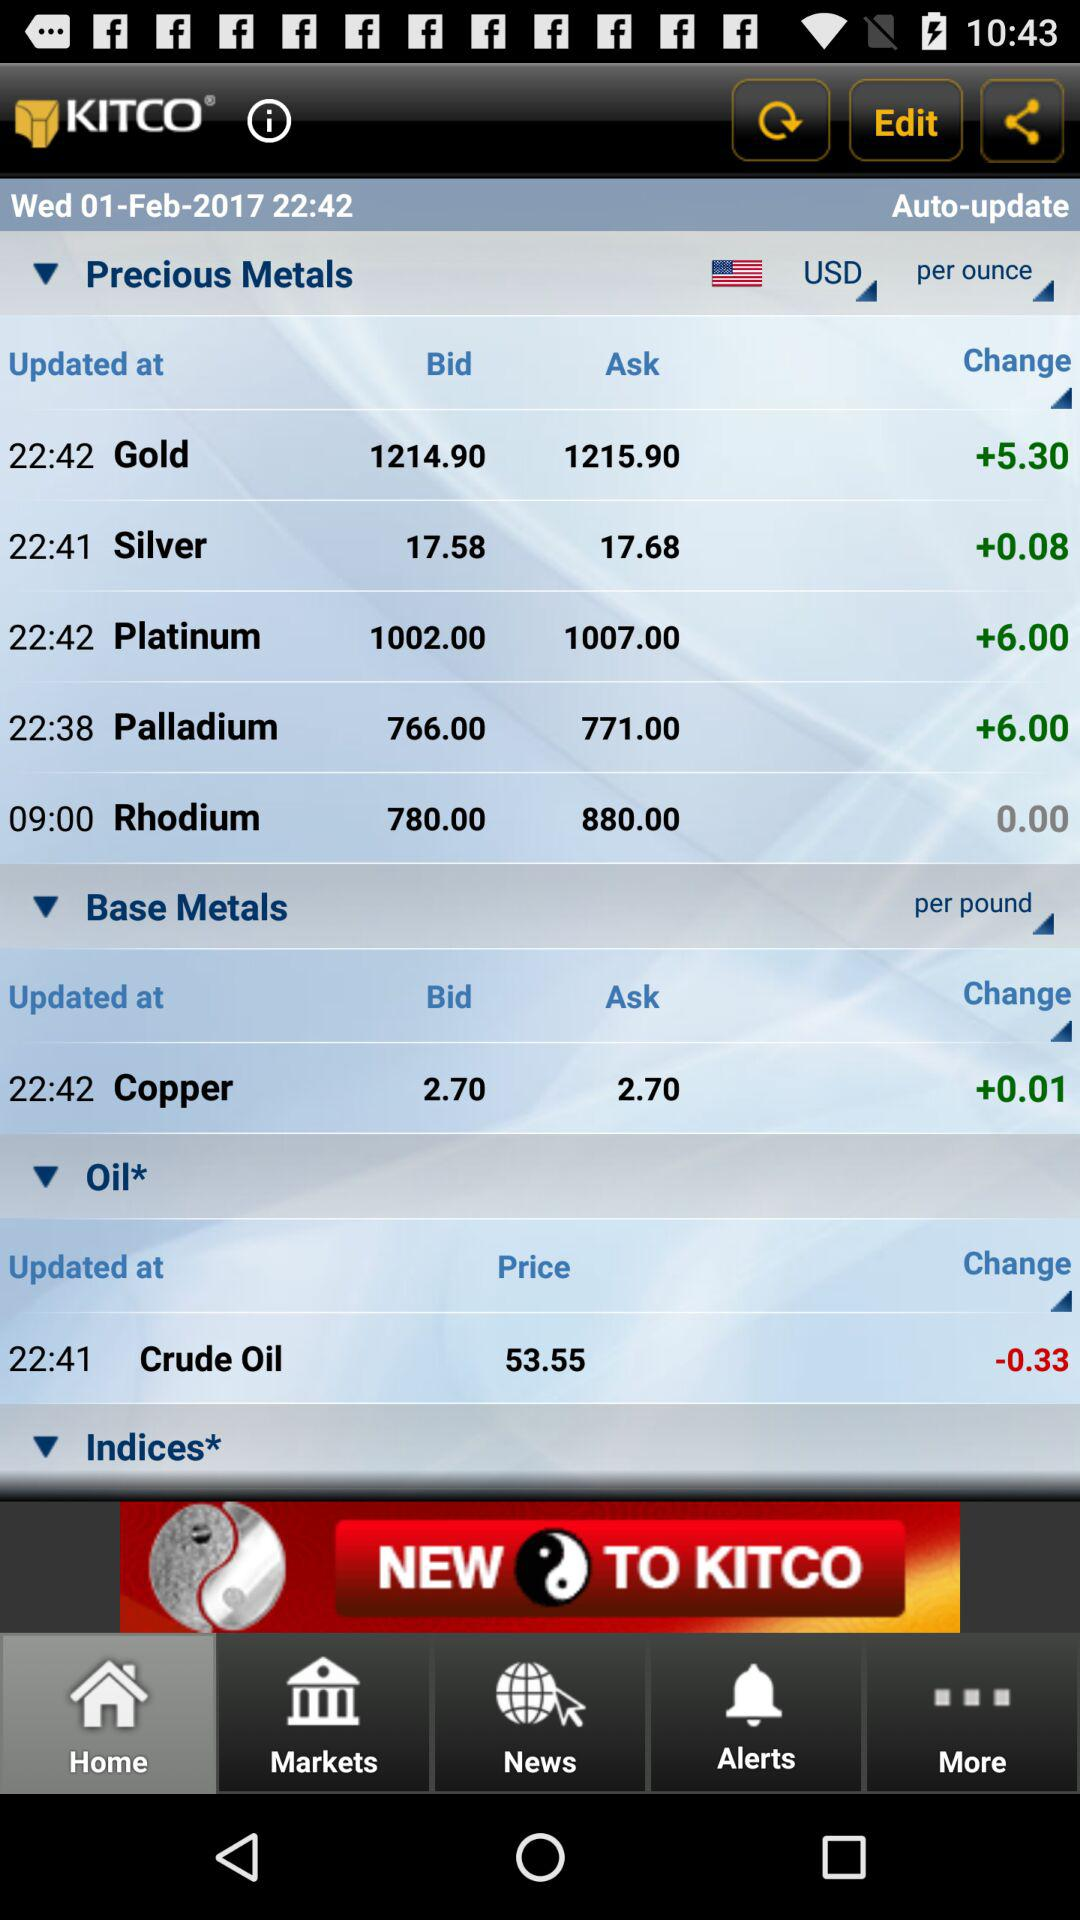Which currency is selected? The selected currency is USD. 